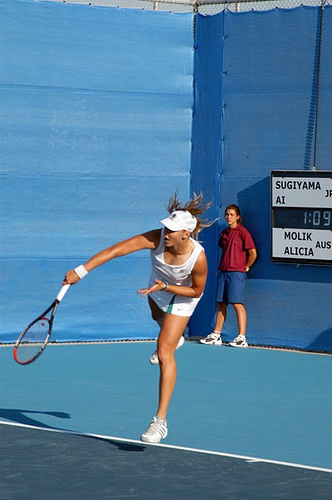Describe the objects in this image and their specific colors. I can see people in lightblue, tan, white, gray, and brown tones, people in lightblue, black, brown, navy, and maroon tones, and tennis racket in lightblue, gray, and black tones in this image. 